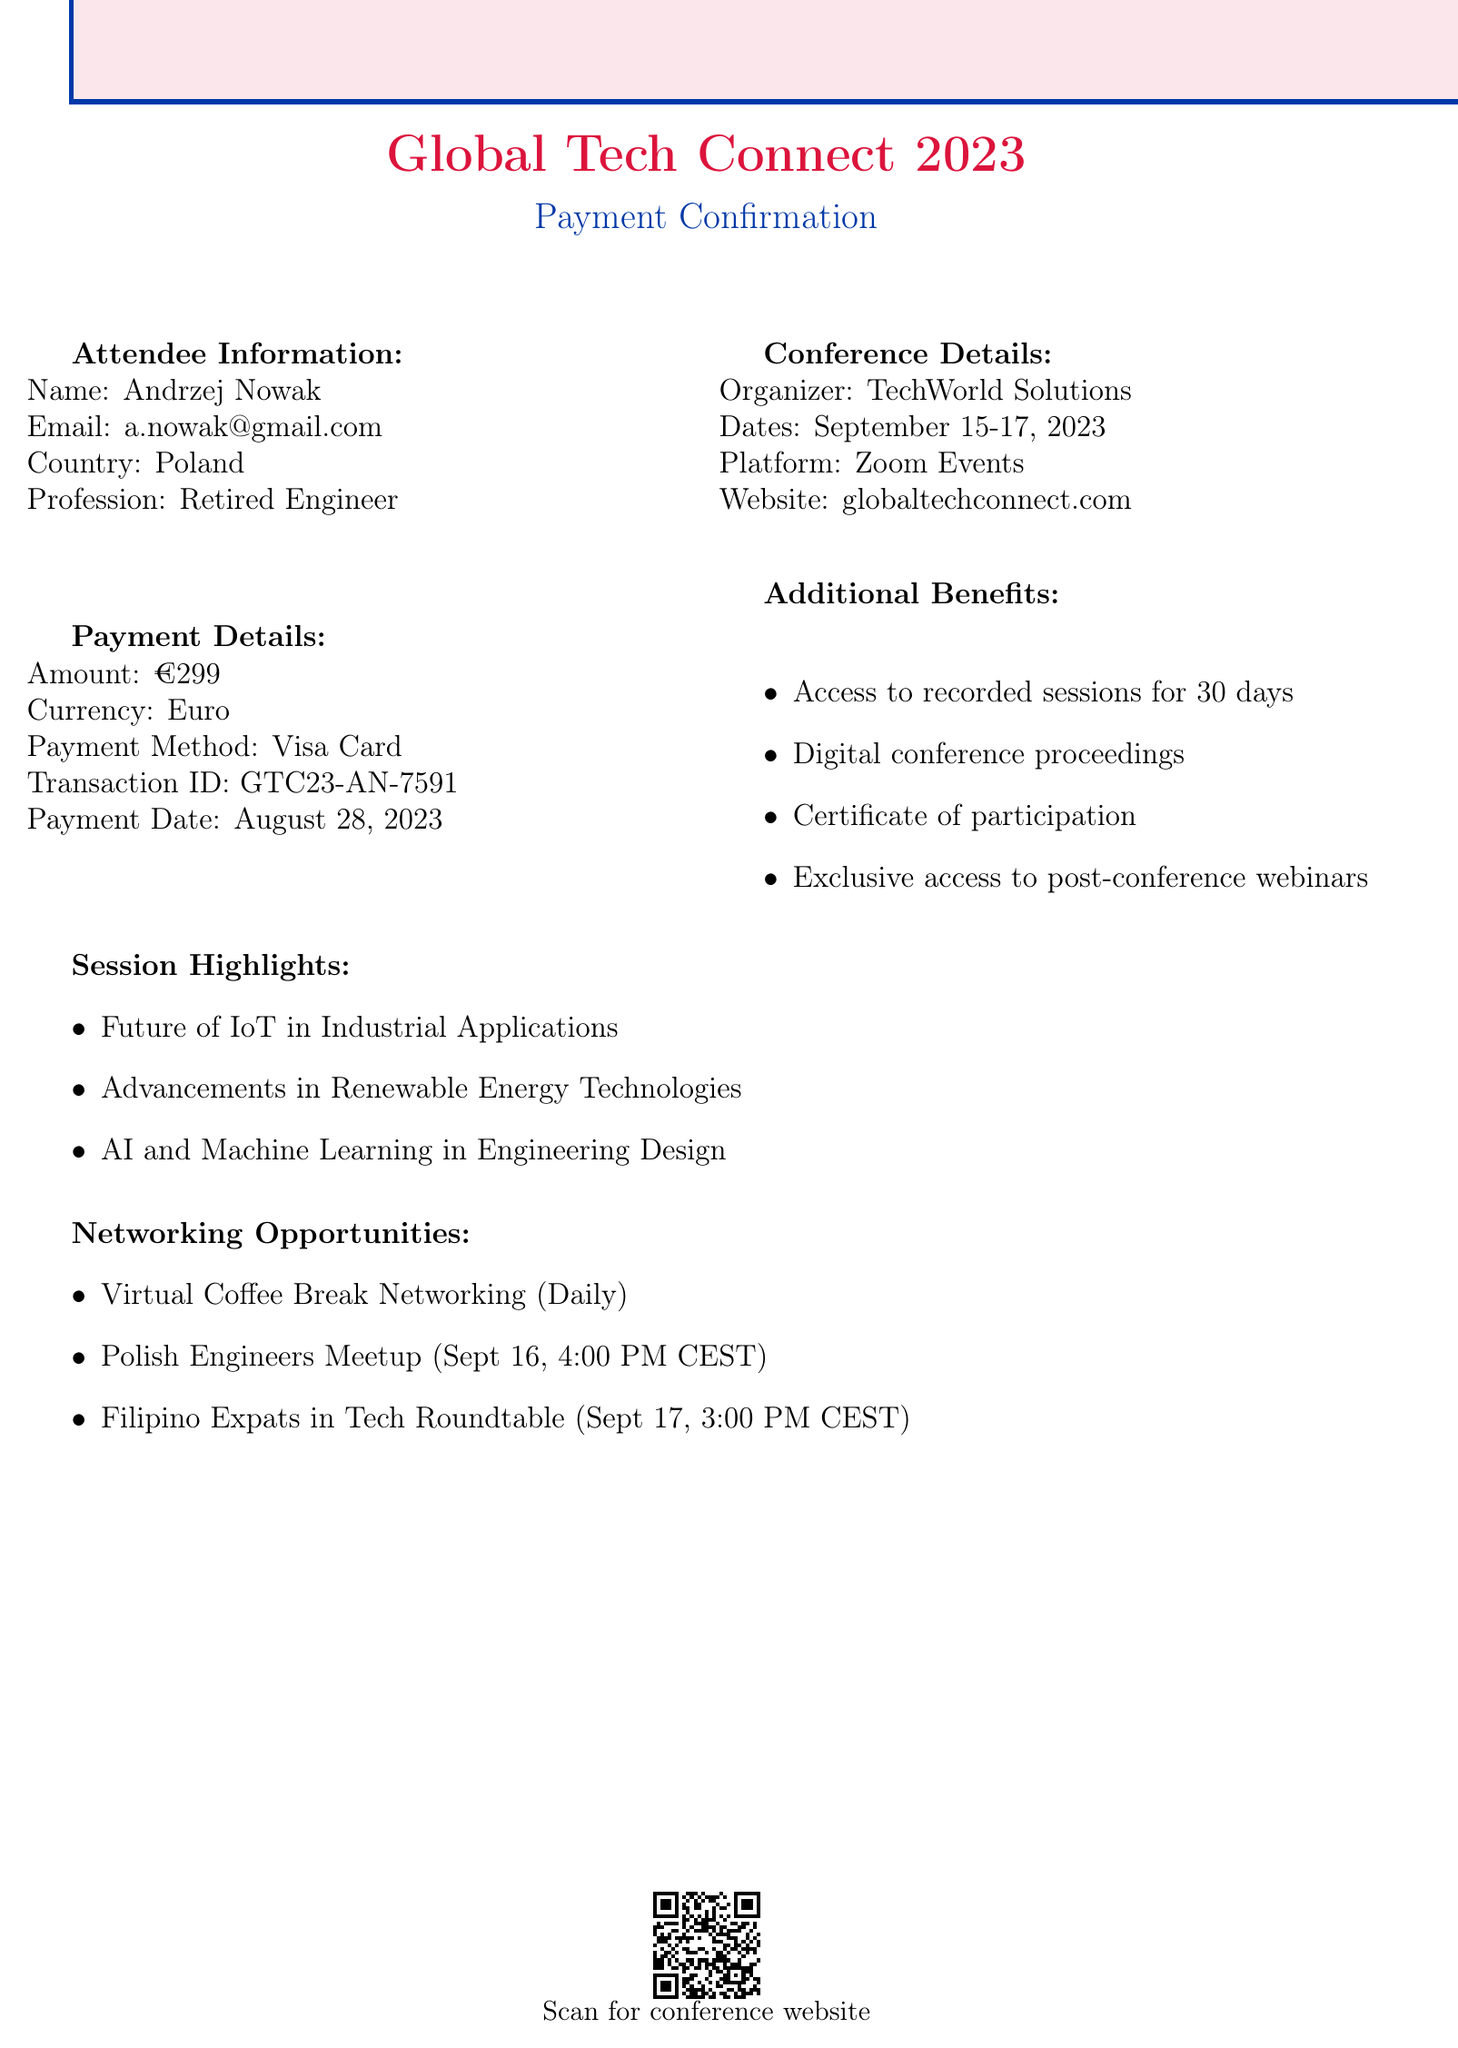What is the name of the conference? The name of the conference is provided in the document and is "Global Tech Connect 2023."
Answer: Global Tech Connect 2023 Who is the organizer of the conference? The organizer of the conference is mentioned in the document as "TechWorld Solutions."
Answer: TechWorld Solutions What is the payment amount? The payment amount is specifically stated in the document as "€299."
Answer: €299 When is the session on "AI and Machine Learning in Engineering Design" scheduled? The date and time for this session are given in the document as "September 17, 2023, 11:00 AM - 12:30 PM CEST."
Answer: September 17, 2023 What is the method of payment used? The document specifies the payment method which is "Visa Card."
Answer: Visa Card How long will recorded sessions be accessible? The document mentions that recorded sessions will be accessible for "30 days after the conference."
Answer: 30 days What special networking session is there for Polish engineers? The document lists a specific networking event for Polish engineers called "Polish Engineers Meetup."
Answer: Polish Engineers Meetup What are the dates of the conference? The document indicates the conference dates as "September 15-17, 2023."
Answer: September 15-17, 2023 How many networking opportunities are mentioned? A count of the listed networking opportunities in the document shows a total of three different events.
Answer: Three 